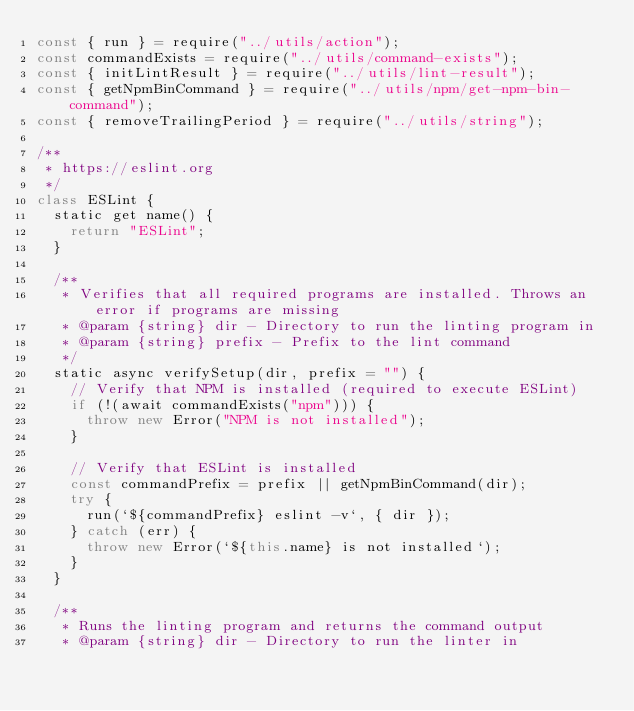<code> <loc_0><loc_0><loc_500><loc_500><_JavaScript_>const { run } = require("../utils/action");
const commandExists = require("../utils/command-exists");
const { initLintResult } = require("../utils/lint-result");
const { getNpmBinCommand } = require("../utils/npm/get-npm-bin-command");
const { removeTrailingPeriod } = require("../utils/string");

/**
 * https://eslint.org
 */
class ESLint {
	static get name() {
		return "ESLint";
	}

	/**
	 * Verifies that all required programs are installed. Throws an error if programs are missing
	 * @param {string} dir - Directory to run the linting program in
	 * @param {string} prefix - Prefix to the lint command
	 */
	static async verifySetup(dir, prefix = "") {
		// Verify that NPM is installed (required to execute ESLint)
		if (!(await commandExists("npm"))) {
			throw new Error("NPM is not installed");
		}

		// Verify that ESLint is installed
		const commandPrefix = prefix || getNpmBinCommand(dir);
		try {
			run(`${commandPrefix} eslint -v`, { dir });
		} catch (err) {
			throw new Error(`${this.name} is not installed`);
		}
	}

	/**
	 * Runs the linting program and returns the command output
	 * @param {string} dir - Directory to run the linter in</code> 